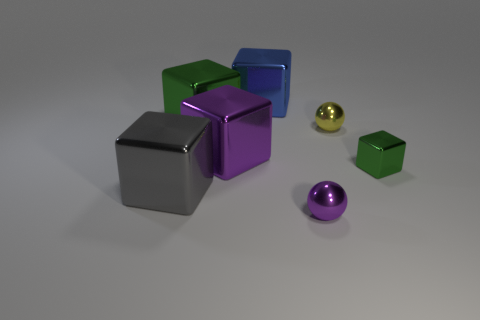There is a large thing that is the same color as the tiny metallic cube; what is its shape?
Your answer should be very brief. Cube. Do the big blue cube and the tiny green object have the same material?
Provide a succinct answer. Yes. There is a large blue object on the right side of the green metal block that is to the left of the yellow object that is behind the small purple ball; what shape is it?
Keep it short and to the point. Cube. Is the number of large metal objects to the right of the big green metallic object less than the number of tiny purple shiny objects to the right of the gray thing?
Provide a short and direct response. No. There is a green metallic thing that is to the right of the green cube on the left side of the blue block; what is its shape?
Ensure brevity in your answer.  Cube. Is there anything else of the same color as the small cube?
Your answer should be compact. Yes. How many red objects are either tiny things or large blocks?
Give a very brief answer. 0. Are there fewer small metallic cubes that are behind the tiny yellow metallic object than gray metal cubes?
Give a very brief answer. Yes. What number of big green cubes are right of the green object right of the small purple ball?
Offer a very short reply. 0. What number of other objects are there of the same size as the blue shiny object?
Make the answer very short. 3. 